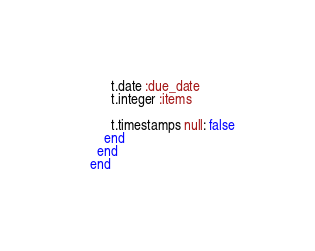Convert code to text. <code><loc_0><loc_0><loc_500><loc_500><_Ruby_>      t.date :due_date
      t.integer :items

      t.timestamps null: false
    end
  end
end
</code> 